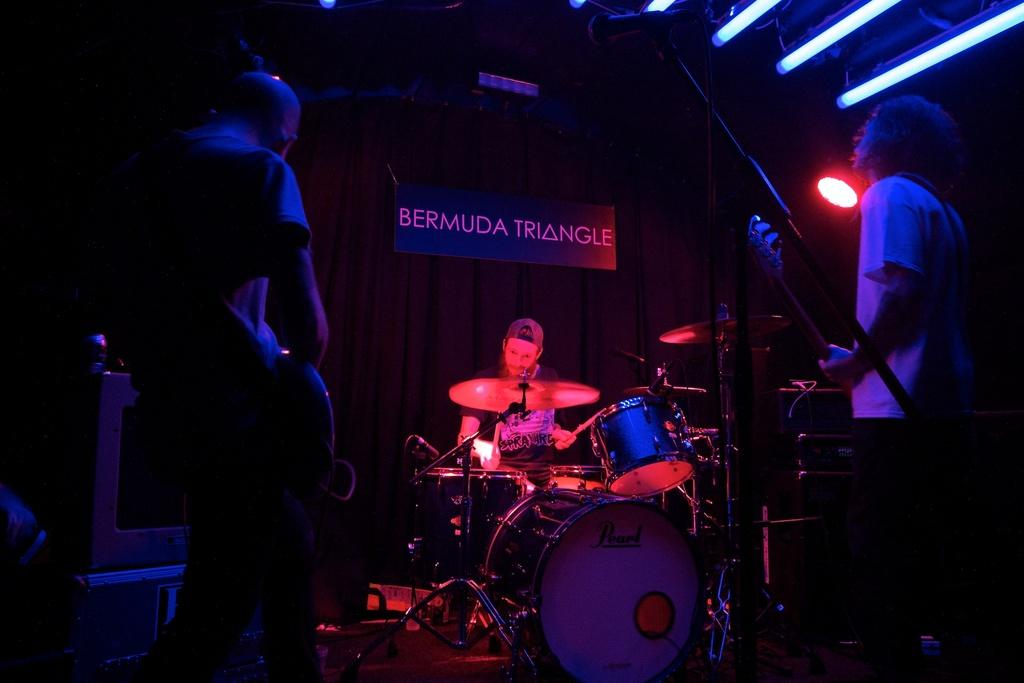What are the people in the image doing? The people in the image are playing musical instruments. What equipment is present to amplify their sound? There are microphones with stands in the image. What electronic devices can be seen in the image? There are devices in the image. What is the purpose of the board in the image? The purpose of the board in the image is not clear, but it could be a music sheet or a prop. What type of lighting is present in the image? There are lights in the image. What type of window treatment is present in the image? There are curtains in the image. How would you describe the overall lighting in the image? The background of the image is dark. What type of shirt is the beginner wearing in the image? There is no mention of a beginner or a shirt in the image. The image features people playing musical instruments, and the focus is on the equipment and setting rather than the clothing of the individuals. 